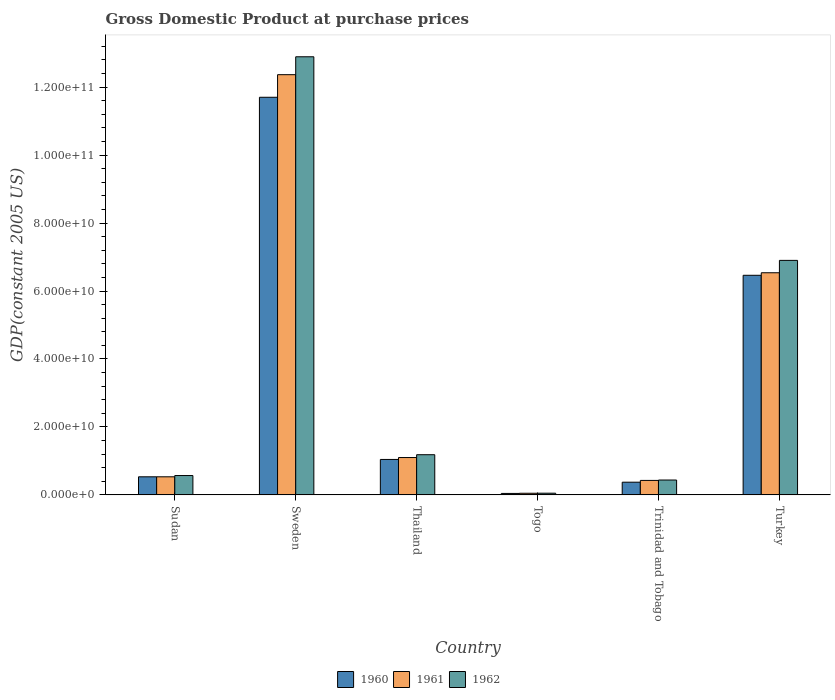Are the number of bars on each tick of the X-axis equal?
Your answer should be compact. Yes. How many bars are there on the 3rd tick from the right?
Your response must be concise. 3. What is the label of the 3rd group of bars from the left?
Your answer should be very brief. Thailand. In how many cases, is the number of bars for a given country not equal to the number of legend labels?
Provide a short and direct response. 0. What is the GDP at purchase prices in 1961 in Thailand?
Give a very brief answer. 1.10e+1. Across all countries, what is the maximum GDP at purchase prices in 1962?
Ensure brevity in your answer.  1.29e+11. Across all countries, what is the minimum GDP at purchase prices in 1962?
Offer a terse response. 5.01e+08. In which country was the GDP at purchase prices in 1962 minimum?
Offer a terse response. Togo. What is the total GDP at purchase prices in 1961 in the graph?
Make the answer very short. 2.10e+11. What is the difference between the GDP at purchase prices in 1962 in Sudan and that in Thailand?
Your answer should be very brief. -6.13e+09. What is the difference between the GDP at purchase prices in 1962 in Trinidad and Tobago and the GDP at purchase prices in 1961 in Turkey?
Offer a terse response. -6.10e+1. What is the average GDP at purchase prices in 1960 per country?
Provide a succinct answer. 3.36e+1. What is the difference between the GDP at purchase prices of/in 1962 and GDP at purchase prices of/in 1960 in Thailand?
Offer a terse response. 1.39e+09. What is the ratio of the GDP at purchase prices in 1961 in Togo to that in Turkey?
Provide a succinct answer. 0.01. Is the GDP at purchase prices in 1960 in Thailand less than that in Turkey?
Keep it short and to the point. Yes. What is the difference between the highest and the second highest GDP at purchase prices in 1960?
Your response must be concise. 1.07e+11. What is the difference between the highest and the lowest GDP at purchase prices in 1961?
Offer a very short reply. 1.23e+11. What does the 3rd bar from the left in Trinidad and Tobago represents?
Your answer should be compact. 1962. Is it the case that in every country, the sum of the GDP at purchase prices in 1962 and GDP at purchase prices in 1960 is greater than the GDP at purchase prices in 1961?
Your answer should be compact. Yes. How many bars are there?
Give a very brief answer. 18. How many countries are there in the graph?
Provide a short and direct response. 6. What is the difference between two consecutive major ticks on the Y-axis?
Your response must be concise. 2.00e+1. Are the values on the major ticks of Y-axis written in scientific E-notation?
Give a very brief answer. Yes. Does the graph contain any zero values?
Keep it short and to the point. No. Does the graph contain grids?
Your response must be concise. No. Where does the legend appear in the graph?
Provide a short and direct response. Bottom center. How many legend labels are there?
Your answer should be very brief. 3. How are the legend labels stacked?
Offer a terse response. Horizontal. What is the title of the graph?
Provide a succinct answer. Gross Domestic Product at purchase prices. Does "1968" appear as one of the legend labels in the graph?
Make the answer very short. No. What is the label or title of the Y-axis?
Ensure brevity in your answer.  GDP(constant 2005 US). What is the GDP(constant 2005 US) in 1960 in Sudan?
Ensure brevity in your answer.  5.32e+09. What is the GDP(constant 2005 US) in 1961 in Sudan?
Your answer should be very brief. 5.33e+09. What is the GDP(constant 2005 US) of 1962 in Sudan?
Give a very brief answer. 5.69e+09. What is the GDP(constant 2005 US) of 1960 in Sweden?
Provide a short and direct response. 1.17e+11. What is the GDP(constant 2005 US) of 1961 in Sweden?
Make the answer very short. 1.24e+11. What is the GDP(constant 2005 US) of 1962 in Sweden?
Offer a terse response. 1.29e+11. What is the GDP(constant 2005 US) of 1960 in Thailand?
Make the answer very short. 1.04e+1. What is the GDP(constant 2005 US) in 1961 in Thailand?
Ensure brevity in your answer.  1.10e+1. What is the GDP(constant 2005 US) of 1962 in Thailand?
Your answer should be compact. 1.18e+1. What is the GDP(constant 2005 US) in 1960 in Togo?
Your answer should be compact. 4.31e+08. What is the GDP(constant 2005 US) in 1961 in Togo?
Provide a short and direct response. 4.83e+08. What is the GDP(constant 2005 US) of 1962 in Togo?
Provide a succinct answer. 5.01e+08. What is the GDP(constant 2005 US) in 1960 in Trinidad and Tobago?
Ensure brevity in your answer.  3.74e+09. What is the GDP(constant 2005 US) in 1961 in Trinidad and Tobago?
Provide a short and direct response. 4.26e+09. What is the GDP(constant 2005 US) of 1962 in Trinidad and Tobago?
Offer a very short reply. 4.38e+09. What is the GDP(constant 2005 US) of 1960 in Turkey?
Your answer should be compact. 6.46e+1. What is the GDP(constant 2005 US) of 1961 in Turkey?
Make the answer very short. 6.54e+1. What is the GDP(constant 2005 US) in 1962 in Turkey?
Your answer should be compact. 6.90e+1. Across all countries, what is the maximum GDP(constant 2005 US) of 1960?
Keep it short and to the point. 1.17e+11. Across all countries, what is the maximum GDP(constant 2005 US) of 1961?
Make the answer very short. 1.24e+11. Across all countries, what is the maximum GDP(constant 2005 US) in 1962?
Provide a short and direct response. 1.29e+11. Across all countries, what is the minimum GDP(constant 2005 US) in 1960?
Keep it short and to the point. 4.31e+08. Across all countries, what is the minimum GDP(constant 2005 US) in 1961?
Keep it short and to the point. 4.83e+08. Across all countries, what is the minimum GDP(constant 2005 US) of 1962?
Provide a short and direct response. 5.01e+08. What is the total GDP(constant 2005 US) in 1960 in the graph?
Provide a succinct answer. 2.02e+11. What is the total GDP(constant 2005 US) in 1961 in the graph?
Your answer should be very brief. 2.10e+11. What is the total GDP(constant 2005 US) in 1962 in the graph?
Offer a very short reply. 2.20e+11. What is the difference between the GDP(constant 2005 US) of 1960 in Sudan and that in Sweden?
Offer a terse response. -1.12e+11. What is the difference between the GDP(constant 2005 US) of 1961 in Sudan and that in Sweden?
Keep it short and to the point. -1.18e+11. What is the difference between the GDP(constant 2005 US) in 1962 in Sudan and that in Sweden?
Provide a short and direct response. -1.23e+11. What is the difference between the GDP(constant 2005 US) in 1960 in Sudan and that in Thailand?
Make the answer very short. -5.11e+09. What is the difference between the GDP(constant 2005 US) of 1961 in Sudan and that in Thailand?
Your answer should be compact. -5.67e+09. What is the difference between the GDP(constant 2005 US) of 1962 in Sudan and that in Thailand?
Your answer should be very brief. -6.13e+09. What is the difference between the GDP(constant 2005 US) of 1960 in Sudan and that in Togo?
Your answer should be very brief. 4.89e+09. What is the difference between the GDP(constant 2005 US) in 1961 in Sudan and that in Togo?
Keep it short and to the point. 4.84e+09. What is the difference between the GDP(constant 2005 US) of 1962 in Sudan and that in Togo?
Give a very brief answer. 5.19e+09. What is the difference between the GDP(constant 2005 US) of 1960 in Sudan and that in Trinidad and Tobago?
Your answer should be compact. 1.59e+09. What is the difference between the GDP(constant 2005 US) in 1961 in Sudan and that in Trinidad and Tobago?
Ensure brevity in your answer.  1.07e+09. What is the difference between the GDP(constant 2005 US) in 1962 in Sudan and that in Trinidad and Tobago?
Ensure brevity in your answer.  1.32e+09. What is the difference between the GDP(constant 2005 US) in 1960 in Sudan and that in Turkey?
Offer a terse response. -5.93e+1. What is the difference between the GDP(constant 2005 US) in 1961 in Sudan and that in Turkey?
Give a very brief answer. -6.01e+1. What is the difference between the GDP(constant 2005 US) of 1962 in Sudan and that in Turkey?
Your answer should be very brief. -6.33e+1. What is the difference between the GDP(constant 2005 US) in 1960 in Sweden and that in Thailand?
Keep it short and to the point. 1.07e+11. What is the difference between the GDP(constant 2005 US) of 1961 in Sweden and that in Thailand?
Offer a very short reply. 1.13e+11. What is the difference between the GDP(constant 2005 US) in 1962 in Sweden and that in Thailand?
Offer a terse response. 1.17e+11. What is the difference between the GDP(constant 2005 US) in 1960 in Sweden and that in Togo?
Provide a short and direct response. 1.17e+11. What is the difference between the GDP(constant 2005 US) in 1961 in Sweden and that in Togo?
Provide a short and direct response. 1.23e+11. What is the difference between the GDP(constant 2005 US) in 1962 in Sweden and that in Togo?
Offer a terse response. 1.28e+11. What is the difference between the GDP(constant 2005 US) in 1960 in Sweden and that in Trinidad and Tobago?
Provide a short and direct response. 1.13e+11. What is the difference between the GDP(constant 2005 US) in 1961 in Sweden and that in Trinidad and Tobago?
Keep it short and to the point. 1.19e+11. What is the difference between the GDP(constant 2005 US) of 1962 in Sweden and that in Trinidad and Tobago?
Make the answer very short. 1.25e+11. What is the difference between the GDP(constant 2005 US) in 1960 in Sweden and that in Turkey?
Give a very brief answer. 5.24e+1. What is the difference between the GDP(constant 2005 US) of 1961 in Sweden and that in Turkey?
Provide a short and direct response. 5.83e+1. What is the difference between the GDP(constant 2005 US) in 1962 in Sweden and that in Turkey?
Give a very brief answer. 5.99e+1. What is the difference between the GDP(constant 2005 US) in 1960 in Thailand and that in Togo?
Provide a short and direct response. 1.00e+1. What is the difference between the GDP(constant 2005 US) of 1961 in Thailand and that in Togo?
Your response must be concise. 1.05e+1. What is the difference between the GDP(constant 2005 US) of 1962 in Thailand and that in Togo?
Provide a succinct answer. 1.13e+1. What is the difference between the GDP(constant 2005 US) of 1960 in Thailand and that in Trinidad and Tobago?
Your answer should be compact. 6.70e+09. What is the difference between the GDP(constant 2005 US) of 1961 in Thailand and that in Trinidad and Tobago?
Provide a short and direct response. 6.73e+09. What is the difference between the GDP(constant 2005 US) of 1962 in Thailand and that in Trinidad and Tobago?
Ensure brevity in your answer.  7.45e+09. What is the difference between the GDP(constant 2005 US) in 1960 in Thailand and that in Turkey?
Keep it short and to the point. -5.42e+1. What is the difference between the GDP(constant 2005 US) of 1961 in Thailand and that in Turkey?
Give a very brief answer. -5.44e+1. What is the difference between the GDP(constant 2005 US) in 1962 in Thailand and that in Turkey?
Your answer should be compact. -5.72e+1. What is the difference between the GDP(constant 2005 US) of 1960 in Togo and that in Trinidad and Tobago?
Provide a succinct answer. -3.30e+09. What is the difference between the GDP(constant 2005 US) of 1961 in Togo and that in Trinidad and Tobago?
Provide a succinct answer. -3.78e+09. What is the difference between the GDP(constant 2005 US) in 1962 in Togo and that in Trinidad and Tobago?
Your answer should be compact. -3.88e+09. What is the difference between the GDP(constant 2005 US) of 1960 in Togo and that in Turkey?
Make the answer very short. -6.42e+1. What is the difference between the GDP(constant 2005 US) in 1961 in Togo and that in Turkey?
Ensure brevity in your answer.  -6.49e+1. What is the difference between the GDP(constant 2005 US) in 1962 in Togo and that in Turkey?
Give a very brief answer. -6.85e+1. What is the difference between the GDP(constant 2005 US) in 1960 in Trinidad and Tobago and that in Turkey?
Make the answer very short. -6.09e+1. What is the difference between the GDP(constant 2005 US) in 1961 in Trinidad and Tobago and that in Turkey?
Provide a succinct answer. -6.11e+1. What is the difference between the GDP(constant 2005 US) in 1962 in Trinidad and Tobago and that in Turkey?
Your answer should be compact. -6.46e+1. What is the difference between the GDP(constant 2005 US) in 1960 in Sudan and the GDP(constant 2005 US) in 1961 in Sweden?
Ensure brevity in your answer.  -1.18e+11. What is the difference between the GDP(constant 2005 US) of 1960 in Sudan and the GDP(constant 2005 US) of 1962 in Sweden?
Ensure brevity in your answer.  -1.24e+11. What is the difference between the GDP(constant 2005 US) of 1961 in Sudan and the GDP(constant 2005 US) of 1962 in Sweden?
Offer a very short reply. -1.24e+11. What is the difference between the GDP(constant 2005 US) of 1960 in Sudan and the GDP(constant 2005 US) of 1961 in Thailand?
Give a very brief answer. -5.67e+09. What is the difference between the GDP(constant 2005 US) in 1960 in Sudan and the GDP(constant 2005 US) in 1962 in Thailand?
Give a very brief answer. -6.50e+09. What is the difference between the GDP(constant 2005 US) of 1961 in Sudan and the GDP(constant 2005 US) of 1962 in Thailand?
Offer a very short reply. -6.50e+09. What is the difference between the GDP(constant 2005 US) of 1960 in Sudan and the GDP(constant 2005 US) of 1961 in Togo?
Ensure brevity in your answer.  4.84e+09. What is the difference between the GDP(constant 2005 US) of 1960 in Sudan and the GDP(constant 2005 US) of 1962 in Togo?
Keep it short and to the point. 4.82e+09. What is the difference between the GDP(constant 2005 US) in 1961 in Sudan and the GDP(constant 2005 US) in 1962 in Togo?
Your answer should be very brief. 4.82e+09. What is the difference between the GDP(constant 2005 US) in 1960 in Sudan and the GDP(constant 2005 US) in 1961 in Trinidad and Tobago?
Your response must be concise. 1.07e+09. What is the difference between the GDP(constant 2005 US) in 1960 in Sudan and the GDP(constant 2005 US) in 1962 in Trinidad and Tobago?
Offer a terse response. 9.48e+08. What is the difference between the GDP(constant 2005 US) in 1961 in Sudan and the GDP(constant 2005 US) in 1962 in Trinidad and Tobago?
Ensure brevity in your answer.  9.50e+08. What is the difference between the GDP(constant 2005 US) in 1960 in Sudan and the GDP(constant 2005 US) in 1961 in Turkey?
Your response must be concise. -6.01e+1. What is the difference between the GDP(constant 2005 US) in 1960 in Sudan and the GDP(constant 2005 US) in 1962 in Turkey?
Make the answer very short. -6.37e+1. What is the difference between the GDP(constant 2005 US) of 1961 in Sudan and the GDP(constant 2005 US) of 1962 in Turkey?
Ensure brevity in your answer.  -6.37e+1. What is the difference between the GDP(constant 2005 US) in 1960 in Sweden and the GDP(constant 2005 US) in 1961 in Thailand?
Make the answer very short. 1.06e+11. What is the difference between the GDP(constant 2005 US) of 1960 in Sweden and the GDP(constant 2005 US) of 1962 in Thailand?
Your response must be concise. 1.05e+11. What is the difference between the GDP(constant 2005 US) in 1961 in Sweden and the GDP(constant 2005 US) in 1962 in Thailand?
Your answer should be very brief. 1.12e+11. What is the difference between the GDP(constant 2005 US) in 1960 in Sweden and the GDP(constant 2005 US) in 1961 in Togo?
Offer a terse response. 1.17e+11. What is the difference between the GDP(constant 2005 US) of 1960 in Sweden and the GDP(constant 2005 US) of 1962 in Togo?
Keep it short and to the point. 1.17e+11. What is the difference between the GDP(constant 2005 US) of 1961 in Sweden and the GDP(constant 2005 US) of 1962 in Togo?
Your answer should be compact. 1.23e+11. What is the difference between the GDP(constant 2005 US) in 1960 in Sweden and the GDP(constant 2005 US) in 1961 in Trinidad and Tobago?
Give a very brief answer. 1.13e+11. What is the difference between the GDP(constant 2005 US) of 1960 in Sweden and the GDP(constant 2005 US) of 1962 in Trinidad and Tobago?
Your answer should be compact. 1.13e+11. What is the difference between the GDP(constant 2005 US) of 1961 in Sweden and the GDP(constant 2005 US) of 1962 in Trinidad and Tobago?
Keep it short and to the point. 1.19e+11. What is the difference between the GDP(constant 2005 US) in 1960 in Sweden and the GDP(constant 2005 US) in 1961 in Turkey?
Give a very brief answer. 5.16e+1. What is the difference between the GDP(constant 2005 US) of 1960 in Sweden and the GDP(constant 2005 US) of 1962 in Turkey?
Keep it short and to the point. 4.80e+1. What is the difference between the GDP(constant 2005 US) of 1961 in Sweden and the GDP(constant 2005 US) of 1962 in Turkey?
Give a very brief answer. 5.47e+1. What is the difference between the GDP(constant 2005 US) in 1960 in Thailand and the GDP(constant 2005 US) in 1961 in Togo?
Keep it short and to the point. 9.95e+09. What is the difference between the GDP(constant 2005 US) in 1960 in Thailand and the GDP(constant 2005 US) in 1962 in Togo?
Ensure brevity in your answer.  9.93e+09. What is the difference between the GDP(constant 2005 US) in 1961 in Thailand and the GDP(constant 2005 US) in 1962 in Togo?
Offer a terse response. 1.05e+1. What is the difference between the GDP(constant 2005 US) in 1960 in Thailand and the GDP(constant 2005 US) in 1961 in Trinidad and Tobago?
Provide a succinct answer. 6.17e+09. What is the difference between the GDP(constant 2005 US) of 1960 in Thailand and the GDP(constant 2005 US) of 1962 in Trinidad and Tobago?
Provide a short and direct response. 6.06e+09. What is the difference between the GDP(constant 2005 US) in 1961 in Thailand and the GDP(constant 2005 US) in 1962 in Trinidad and Tobago?
Provide a short and direct response. 6.62e+09. What is the difference between the GDP(constant 2005 US) in 1960 in Thailand and the GDP(constant 2005 US) in 1961 in Turkey?
Offer a terse response. -5.49e+1. What is the difference between the GDP(constant 2005 US) of 1960 in Thailand and the GDP(constant 2005 US) of 1962 in Turkey?
Ensure brevity in your answer.  -5.86e+1. What is the difference between the GDP(constant 2005 US) in 1961 in Thailand and the GDP(constant 2005 US) in 1962 in Turkey?
Offer a very short reply. -5.80e+1. What is the difference between the GDP(constant 2005 US) in 1960 in Togo and the GDP(constant 2005 US) in 1961 in Trinidad and Tobago?
Your answer should be very brief. -3.83e+09. What is the difference between the GDP(constant 2005 US) of 1960 in Togo and the GDP(constant 2005 US) of 1962 in Trinidad and Tobago?
Your answer should be compact. -3.95e+09. What is the difference between the GDP(constant 2005 US) of 1961 in Togo and the GDP(constant 2005 US) of 1962 in Trinidad and Tobago?
Offer a very short reply. -3.89e+09. What is the difference between the GDP(constant 2005 US) of 1960 in Togo and the GDP(constant 2005 US) of 1961 in Turkey?
Your response must be concise. -6.49e+1. What is the difference between the GDP(constant 2005 US) in 1960 in Togo and the GDP(constant 2005 US) in 1962 in Turkey?
Provide a short and direct response. -6.86e+1. What is the difference between the GDP(constant 2005 US) of 1961 in Togo and the GDP(constant 2005 US) of 1962 in Turkey?
Your answer should be compact. -6.85e+1. What is the difference between the GDP(constant 2005 US) in 1960 in Trinidad and Tobago and the GDP(constant 2005 US) in 1961 in Turkey?
Offer a very short reply. -6.16e+1. What is the difference between the GDP(constant 2005 US) of 1960 in Trinidad and Tobago and the GDP(constant 2005 US) of 1962 in Turkey?
Give a very brief answer. -6.53e+1. What is the difference between the GDP(constant 2005 US) in 1961 in Trinidad and Tobago and the GDP(constant 2005 US) in 1962 in Turkey?
Keep it short and to the point. -6.48e+1. What is the average GDP(constant 2005 US) in 1960 per country?
Provide a short and direct response. 3.36e+1. What is the average GDP(constant 2005 US) of 1961 per country?
Make the answer very short. 3.50e+1. What is the average GDP(constant 2005 US) of 1962 per country?
Make the answer very short. 3.67e+1. What is the difference between the GDP(constant 2005 US) in 1960 and GDP(constant 2005 US) in 1961 in Sudan?
Your response must be concise. -1.19e+06. What is the difference between the GDP(constant 2005 US) in 1960 and GDP(constant 2005 US) in 1962 in Sudan?
Offer a very short reply. -3.70e+08. What is the difference between the GDP(constant 2005 US) in 1961 and GDP(constant 2005 US) in 1962 in Sudan?
Give a very brief answer. -3.68e+08. What is the difference between the GDP(constant 2005 US) of 1960 and GDP(constant 2005 US) of 1961 in Sweden?
Provide a succinct answer. -6.65e+09. What is the difference between the GDP(constant 2005 US) of 1960 and GDP(constant 2005 US) of 1962 in Sweden?
Keep it short and to the point. -1.19e+1. What is the difference between the GDP(constant 2005 US) in 1961 and GDP(constant 2005 US) in 1962 in Sweden?
Ensure brevity in your answer.  -5.27e+09. What is the difference between the GDP(constant 2005 US) in 1960 and GDP(constant 2005 US) in 1961 in Thailand?
Make the answer very short. -5.60e+08. What is the difference between the GDP(constant 2005 US) in 1960 and GDP(constant 2005 US) in 1962 in Thailand?
Make the answer very short. -1.39e+09. What is the difference between the GDP(constant 2005 US) in 1961 and GDP(constant 2005 US) in 1962 in Thailand?
Keep it short and to the point. -8.31e+08. What is the difference between the GDP(constant 2005 US) in 1960 and GDP(constant 2005 US) in 1961 in Togo?
Provide a succinct answer. -5.24e+07. What is the difference between the GDP(constant 2005 US) of 1960 and GDP(constant 2005 US) of 1962 in Togo?
Provide a short and direct response. -7.06e+07. What is the difference between the GDP(constant 2005 US) of 1961 and GDP(constant 2005 US) of 1962 in Togo?
Your answer should be very brief. -1.82e+07. What is the difference between the GDP(constant 2005 US) in 1960 and GDP(constant 2005 US) in 1961 in Trinidad and Tobago?
Your response must be concise. -5.24e+08. What is the difference between the GDP(constant 2005 US) of 1960 and GDP(constant 2005 US) of 1962 in Trinidad and Tobago?
Ensure brevity in your answer.  -6.41e+08. What is the difference between the GDP(constant 2005 US) in 1961 and GDP(constant 2005 US) in 1962 in Trinidad and Tobago?
Provide a short and direct response. -1.17e+08. What is the difference between the GDP(constant 2005 US) in 1960 and GDP(constant 2005 US) in 1961 in Turkey?
Your answer should be very brief. -7.47e+08. What is the difference between the GDP(constant 2005 US) of 1960 and GDP(constant 2005 US) of 1962 in Turkey?
Your response must be concise. -4.39e+09. What is the difference between the GDP(constant 2005 US) in 1961 and GDP(constant 2005 US) in 1962 in Turkey?
Provide a short and direct response. -3.64e+09. What is the ratio of the GDP(constant 2005 US) of 1960 in Sudan to that in Sweden?
Your response must be concise. 0.05. What is the ratio of the GDP(constant 2005 US) of 1961 in Sudan to that in Sweden?
Offer a terse response. 0.04. What is the ratio of the GDP(constant 2005 US) of 1962 in Sudan to that in Sweden?
Your response must be concise. 0.04. What is the ratio of the GDP(constant 2005 US) of 1960 in Sudan to that in Thailand?
Your answer should be compact. 0.51. What is the ratio of the GDP(constant 2005 US) in 1961 in Sudan to that in Thailand?
Provide a short and direct response. 0.48. What is the ratio of the GDP(constant 2005 US) of 1962 in Sudan to that in Thailand?
Make the answer very short. 0.48. What is the ratio of the GDP(constant 2005 US) in 1960 in Sudan to that in Togo?
Offer a very short reply. 12.36. What is the ratio of the GDP(constant 2005 US) of 1961 in Sudan to that in Togo?
Keep it short and to the point. 11.02. What is the ratio of the GDP(constant 2005 US) in 1962 in Sudan to that in Togo?
Your answer should be very brief. 11.36. What is the ratio of the GDP(constant 2005 US) in 1960 in Sudan to that in Trinidad and Tobago?
Your answer should be compact. 1.43. What is the ratio of the GDP(constant 2005 US) of 1961 in Sudan to that in Trinidad and Tobago?
Offer a very short reply. 1.25. What is the ratio of the GDP(constant 2005 US) in 1962 in Sudan to that in Trinidad and Tobago?
Ensure brevity in your answer.  1.3. What is the ratio of the GDP(constant 2005 US) in 1960 in Sudan to that in Turkey?
Provide a succinct answer. 0.08. What is the ratio of the GDP(constant 2005 US) of 1961 in Sudan to that in Turkey?
Make the answer very short. 0.08. What is the ratio of the GDP(constant 2005 US) in 1962 in Sudan to that in Turkey?
Give a very brief answer. 0.08. What is the ratio of the GDP(constant 2005 US) in 1960 in Sweden to that in Thailand?
Give a very brief answer. 11.22. What is the ratio of the GDP(constant 2005 US) of 1961 in Sweden to that in Thailand?
Make the answer very short. 11.25. What is the ratio of the GDP(constant 2005 US) in 1962 in Sweden to that in Thailand?
Keep it short and to the point. 10.9. What is the ratio of the GDP(constant 2005 US) in 1960 in Sweden to that in Togo?
Keep it short and to the point. 271.68. What is the ratio of the GDP(constant 2005 US) of 1961 in Sweden to that in Togo?
Your answer should be compact. 255.97. What is the ratio of the GDP(constant 2005 US) in 1962 in Sweden to that in Togo?
Keep it short and to the point. 257.16. What is the ratio of the GDP(constant 2005 US) of 1960 in Sweden to that in Trinidad and Tobago?
Offer a terse response. 31.33. What is the ratio of the GDP(constant 2005 US) in 1961 in Sweden to that in Trinidad and Tobago?
Offer a terse response. 29.03. What is the ratio of the GDP(constant 2005 US) of 1962 in Sweden to that in Trinidad and Tobago?
Offer a very short reply. 29.46. What is the ratio of the GDP(constant 2005 US) in 1960 in Sweden to that in Turkey?
Offer a terse response. 1.81. What is the ratio of the GDP(constant 2005 US) in 1961 in Sweden to that in Turkey?
Ensure brevity in your answer.  1.89. What is the ratio of the GDP(constant 2005 US) of 1962 in Sweden to that in Turkey?
Give a very brief answer. 1.87. What is the ratio of the GDP(constant 2005 US) of 1960 in Thailand to that in Togo?
Provide a succinct answer. 24.22. What is the ratio of the GDP(constant 2005 US) of 1961 in Thailand to that in Togo?
Your answer should be very brief. 22.75. What is the ratio of the GDP(constant 2005 US) in 1962 in Thailand to that in Togo?
Keep it short and to the point. 23.58. What is the ratio of the GDP(constant 2005 US) in 1960 in Thailand to that in Trinidad and Tobago?
Provide a short and direct response. 2.79. What is the ratio of the GDP(constant 2005 US) in 1961 in Thailand to that in Trinidad and Tobago?
Ensure brevity in your answer.  2.58. What is the ratio of the GDP(constant 2005 US) of 1962 in Thailand to that in Trinidad and Tobago?
Provide a succinct answer. 2.7. What is the ratio of the GDP(constant 2005 US) in 1960 in Thailand to that in Turkey?
Provide a succinct answer. 0.16. What is the ratio of the GDP(constant 2005 US) in 1961 in Thailand to that in Turkey?
Your response must be concise. 0.17. What is the ratio of the GDP(constant 2005 US) in 1962 in Thailand to that in Turkey?
Your answer should be compact. 0.17. What is the ratio of the GDP(constant 2005 US) in 1960 in Togo to that in Trinidad and Tobago?
Offer a terse response. 0.12. What is the ratio of the GDP(constant 2005 US) in 1961 in Togo to that in Trinidad and Tobago?
Give a very brief answer. 0.11. What is the ratio of the GDP(constant 2005 US) of 1962 in Togo to that in Trinidad and Tobago?
Ensure brevity in your answer.  0.11. What is the ratio of the GDP(constant 2005 US) in 1960 in Togo to that in Turkey?
Make the answer very short. 0.01. What is the ratio of the GDP(constant 2005 US) of 1961 in Togo to that in Turkey?
Provide a short and direct response. 0.01. What is the ratio of the GDP(constant 2005 US) of 1962 in Togo to that in Turkey?
Your answer should be very brief. 0.01. What is the ratio of the GDP(constant 2005 US) in 1960 in Trinidad and Tobago to that in Turkey?
Provide a succinct answer. 0.06. What is the ratio of the GDP(constant 2005 US) of 1961 in Trinidad and Tobago to that in Turkey?
Give a very brief answer. 0.07. What is the ratio of the GDP(constant 2005 US) in 1962 in Trinidad and Tobago to that in Turkey?
Ensure brevity in your answer.  0.06. What is the difference between the highest and the second highest GDP(constant 2005 US) of 1960?
Offer a terse response. 5.24e+1. What is the difference between the highest and the second highest GDP(constant 2005 US) of 1961?
Make the answer very short. 5.83e+1. What is the difference between the highest and the second highest GDP(constant 2005 US) in 1962?
Your response must be concise. 5.99e+1. What is the difference between the highest and the lowest GDP(constant 2005 US) of 1960?
Offer a very short reply. 1.17e+11. What is the difference between the highest and the lowest GDP(constant 2005 US) in 1961?
Offer a terse response. 1.23e+11. What is the difference between the highest and the lowest GDP(constant 2005 US) of 1962?
Keep it short and to the point. 1.28e+11. 